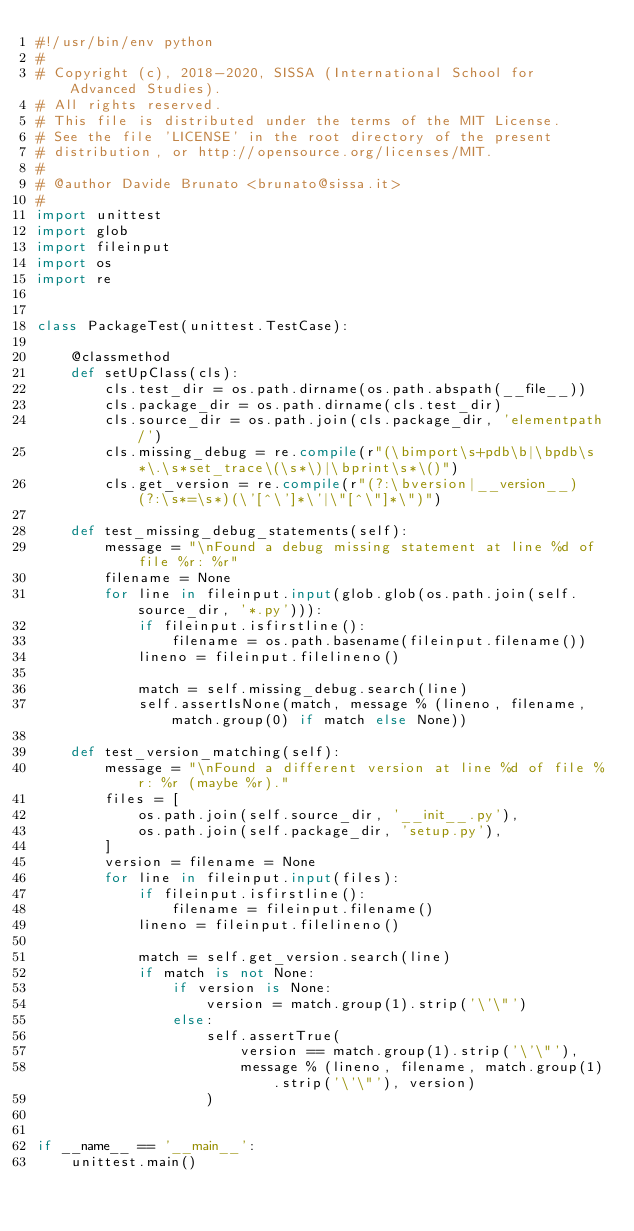<code> <loc_0><loc_0><loc_500><loc_500><_Python_>#!/usr/bin/env python
#
# Copyright (c), 2018-2020, SISSA (International School for Advanced Studies).
# All rights reserved.
# This file is distributed under the terms of the MIT License.
# See the file 'LICENSE' in the root directory of the present
# distribution, or http://opensource.org/licenses/MIT.
#
# @author Davide Brunato <brunato@sissa.it>
#
import unittest
import glob
import fileinput
import os
import re


class PackageTest(unittest.TestCase):

    @classmethod
    def setUpClass(cls):
        cls.test_dir = os.path.dirname(os.path.abspath(__file__))
        cls.package_dir = os.path.dirname(cls.test_dir)
        cls.source_dir = os.path.join(cls.package_dir, 'elementpath/')
        cls.missing_debug = re.compile(r"(\bimport\s+pdb\b|\bpdb\s*\.\s*set_trace\(\s*\)|\bprint\s*\()")
        cls.get_version = re.compile(r"(?:\bversion|__version__)(?:\s*=\s*)(\'[^\']*\'|\"[^\"]*\")")

    def test_missing_debug_statements(self):
        message = "\nFound a debug missing statement at line %d of file %r: %r"
        filename = None
        for line in fileinput.input(glob.glob(os.path.join(self.source_dir, '*.py'))):
            if fileinput.isfirstline():
                filename = os.path.basename(fileinput.filename())
            lineno = fileinput.filelineno()

            match = self.missing_debug.search(line)
            self.assertIsNone(match, message % (lineno, filename, match.group(0) if match else None))

    def test_version_matching(self):
        message = "\nFound a different version at line %d of file %r: %r (maybe %r)."
        files = [
            os.path.join(self.source_dir, '__init__.py'),
            os.path.join(self.package_dir, 'setup.py'),
        ]
        version = filename = None
        for line in fileinput.input(files):
            if fileinput.isfirstline():
                filename = fileinput.filename()
            lineno = fileinput.filelineno()

            match = self.get_version.search(line)
            if match is not None:
                if version is None:
                    version = match.group(1).strip('\'\"')
                else:
                    self.assertTrue(
                        version == match.group(1).strip('\'\"'),
                        message % (lineno, filename, match.group(1).strip('\'\"'), version)
                    )


if __name__ == '__main__':
    unittest.main()
</code> 